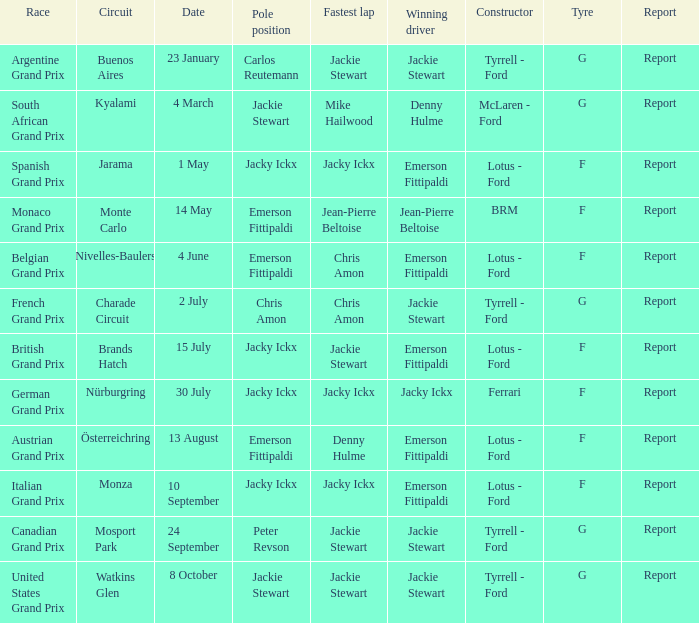What day did Emerson Fittipaldi win the Spanish Grand Prix? 1 May. 